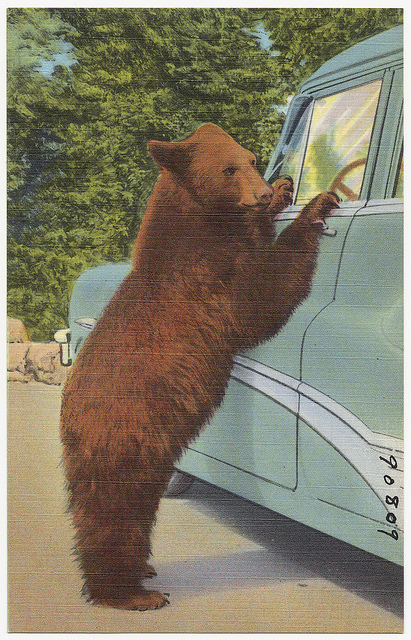Identify the text displayed in this image. 90908 